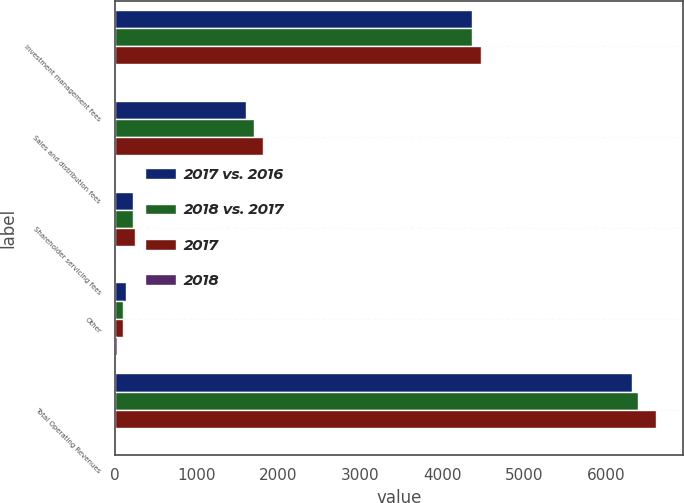Convert chart to OTSL. <chart><loc_0><loc_0><loc_500><loc_500><stacked_bar_chart><ecel><fcel>Investment management fees<fcel>Sales and distribution fees<fcel>Shareholder servicing fees<fcel>Other<fcel>Total Operating Revenues<nl><fcel>2017 vs. 2016<fcel>4367.5<fcel>1599.8<fcel>221.9<fcel>129.9<fcel>6319.1<nl><fcel>2018 vs. 2017<fcel>4359.2<fcel>1705.6<fcel>225.7<fcel>101.7<fcel>6392.2<nl><fcel>2017<fcel>4471.7<fcel>1806.4<fcel>243.6<fcel>96.3<fcel>6618<nl><fcel>2018<fcel>0<fcel>6<fcel>2<fcel>28<fcel>1<nl></chart> 